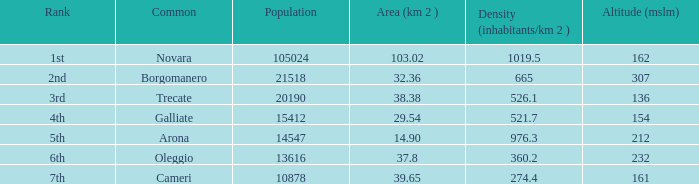Where does the galliate common rank in terms of population? 4th. 